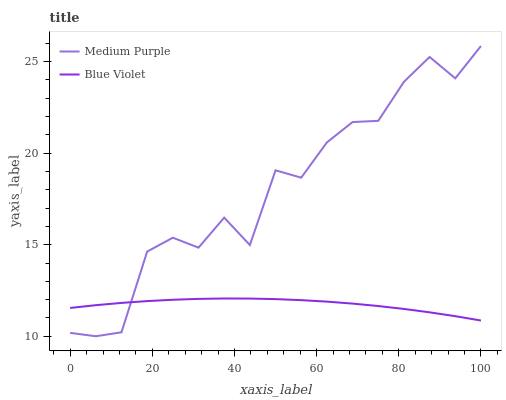Does Blue Violet have the maximum area under the curve?
Answer yes or no. No. Is Blue Violet the roughest?
Answer yes or no. No. Does Blue Violet have the lowest value?
Answer yes or no. No. Does Blue Violet have the highest value?
Answer yes or no. No. 